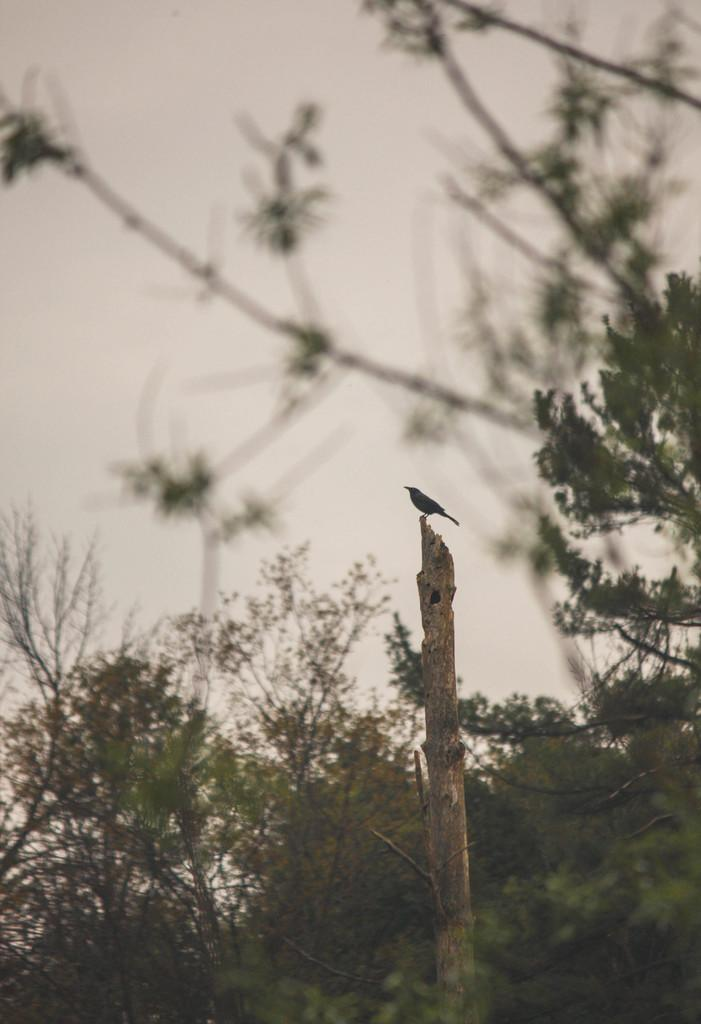What type of animal is in the image? There is a bird in the image. What is the bird standing on? The bird is standing on a wooden stick. What can be seen in the background of the image? There are trees and the sky visible in the background of the image. What type of minister is present in the image? There is no minister present in the image; it features a bird standing on a wooden stick with trees and the sky visible in the background. 